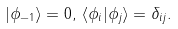Convert formula to latex. <formula><loc_0><loc_0><loc_500><loc_500>| \phi _ { - 1 } \rangle = 0 , \, \langle \phi _ { i } | \phi _ { j } \rangle = \delta _ { i j } .</formula> 